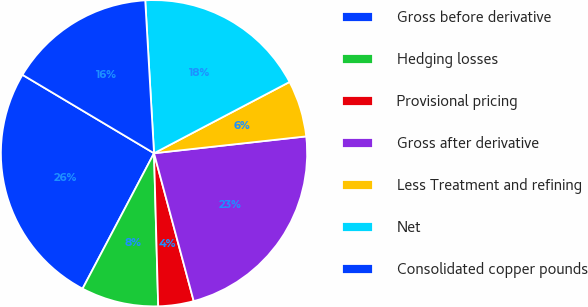Convert chart. <chart><loc_0><loc_0><loc_500><loc_500><pie_chart><fcel>Gross before derivative<fcel>Hedging losses<fcel>Provisional pricing<fcel>Gross after derivative<fcel>Less Treatment and refining<fcel>Net<fcel>Consolidated copper pounds<nl><fcel>25.83%<fcel>8.16%<fcel>3.74%<fcel>22.58%<fcel>5.95%<fcel>18.21%<fcel>15.53%<nl></chart> 